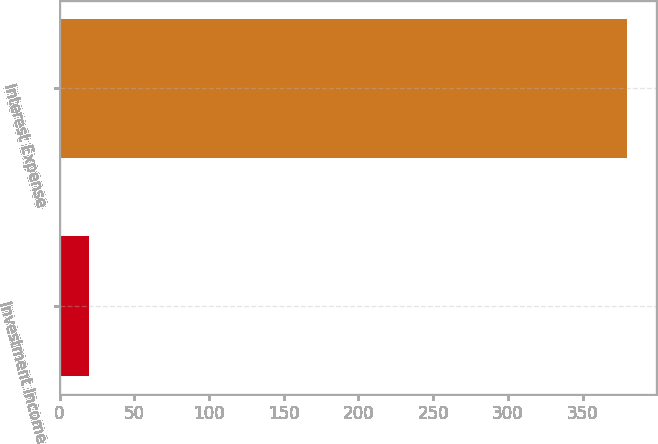<chart> <loc_0><loc_0><loc_500><loc_500><bar_chart><fcel>Investment Income<fcel>Interest Expense<nl><fcel>20<fcel>380<nl></chart> 